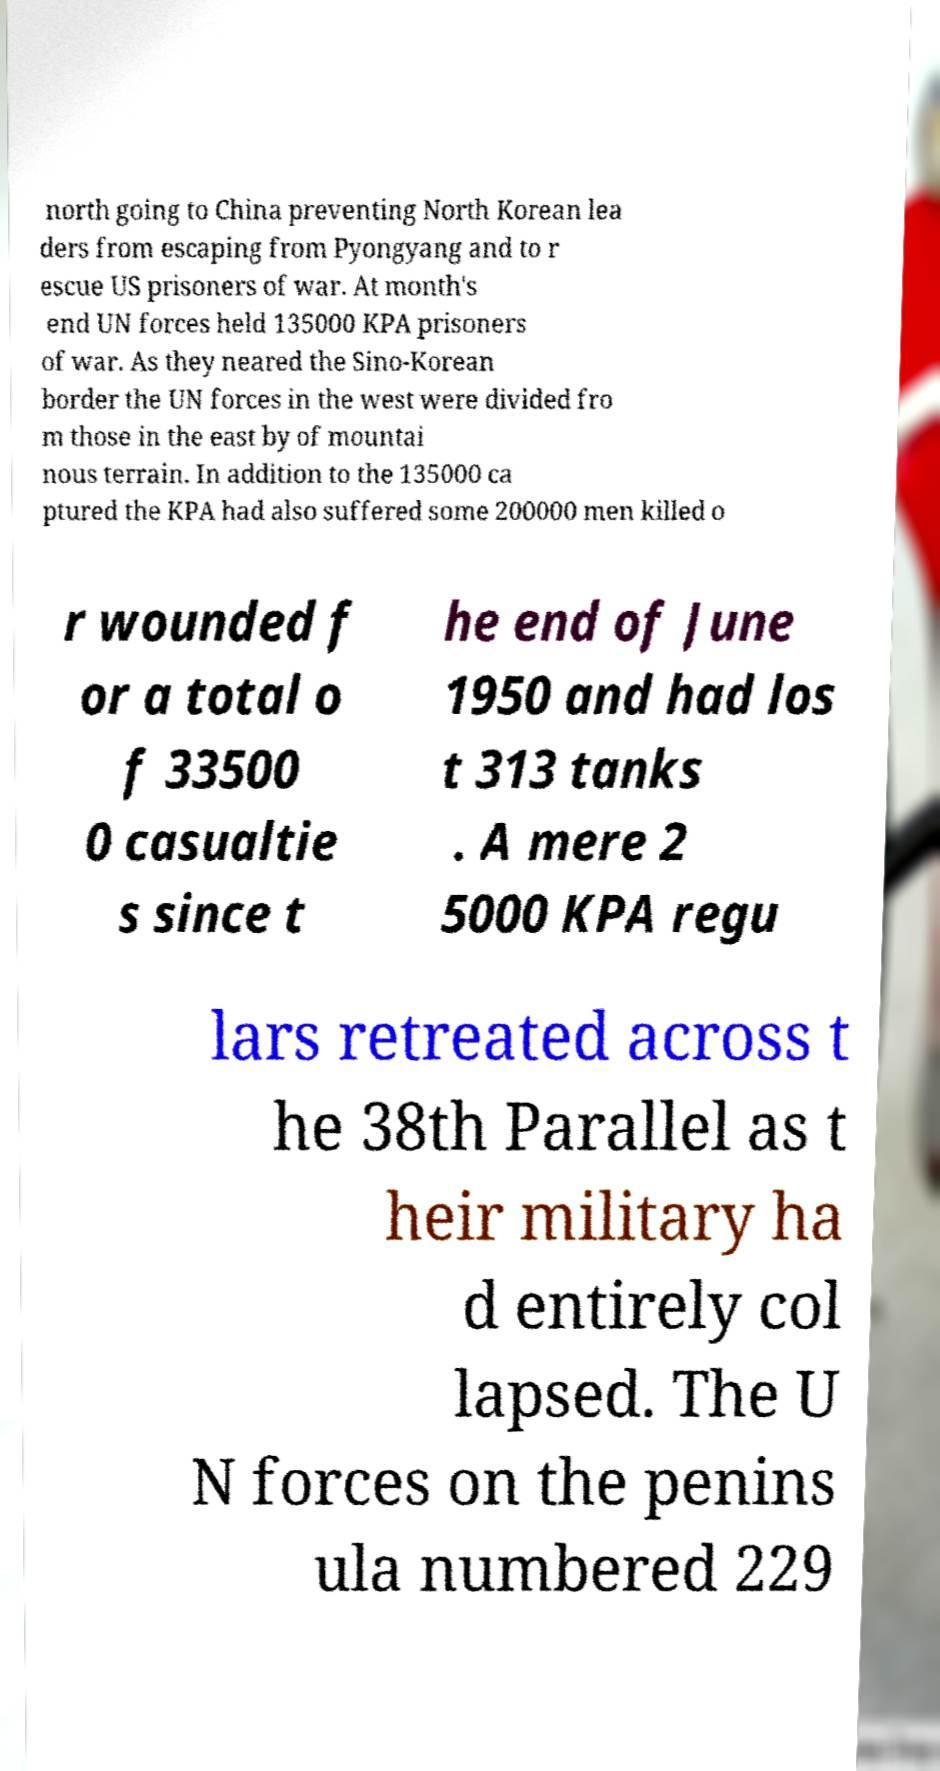Can you read and provide the text displayed in the image?This photo seems to have some interesting text. Can you extract and type it out for me? north going to China preventing North Korean lea ders from escaping from Pyongyang and to r escue US prisoners of war. At month's end UN forces held 135000 KPA prisoners of war. As they neared the Sino-Korean border the UN forces in the west were divided fro m those in the east by of mountai nous terrain. In addition to the 135000 ca ptured the KPA had also suffered some 200000 men killed o r wounded f or a total o f 33500 0 casualtie s since t he end of June 1950 and had los t 313 tanks . A mere 2 5000 KPA regu lars retreated across t he 38th Parallel as t heir military ha d entirely col lapsed. The U N forces on the penins ula numbered 229 